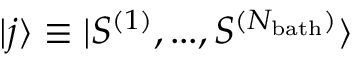<formula> <loc_0><loc_0><loc_500><loc_500>| j \rangle \equiv | S ^ { ( 1 ) } , \dots , S ^ { ( N _ { b a t h } ) } \rangle</formula> 